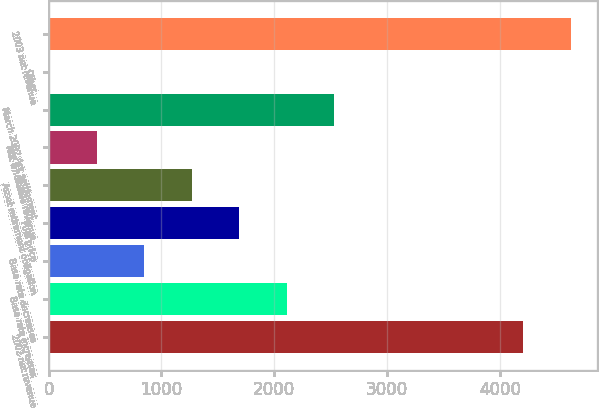<chart> <loc_0><loc_0><loc_500><loc_500><bar_chart><fcel>2002 net revenue<fcel>Base rate increases<fcel>Base rate decreases<fcel>Fuel price<fcel>Asset retirement obligation<fcel>Net wholesale revenue<fcel>March 2002 Ark settlement<fcel>Other<fcel>2003 net revenue<nl><fcel>4209.6<fcel>2110.4<fcel>847.94<fcel>1689.58<fcel>1268.76<fcel>427.12<fcel>2531.22<fcel>6.3<fcel>4630.42<nl></chart> 